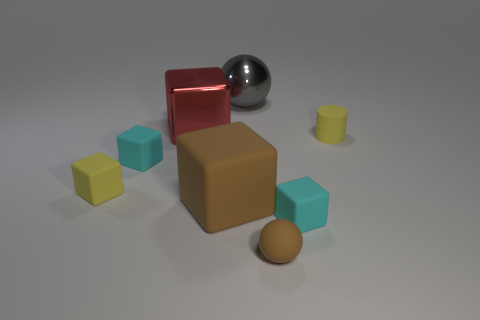Subtract all big brown rubber blocks. How many blocks are left? 4 Subtract all blue balls. How many cyan blocks are left? 2 Add 1 metal cubes. How many objects exist? 9 Subtract 3 cubes. How many cubes are left? 2 Subtract all cyan cubes. How many cubes are left? 3 Subtract all cylinders. How many objects are left? 7 Add 2 small rubber cubes. How many small rubber cubes are left? 5 Add 5 big rubber cubes. How many big rubber cubes exist? 6 Subtract 0 blue blocks. How many objects are left? 8 Subtract all red spheres. Subtract all red blocks. How many spheres are left? 2 